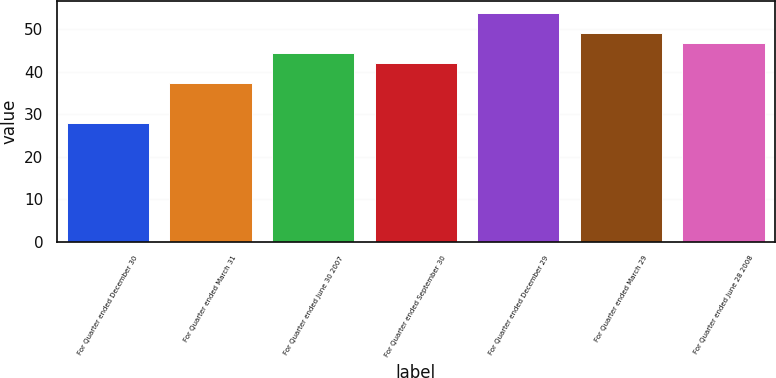Convert chart to OTSL. <chart><loc_0><loc_0><loc_500><loc_500><bar_chart><fcel>For Quarter ended December 30<fcel>For Quarter ended March 31<fcel>For Quarter ended June 30 2007<fcel>For Quarter ended September 30<fcel>For Quarter ended December 29<fcel>For Quarter ended March 29<fcel>For Quarter ended June 28 2008<nl><fcel>27.89<fcel>37.22<fcel>44.38<fcel>42.01<fcel>53.86<fcel>49.12<fcel>46.75<nl></chart> 